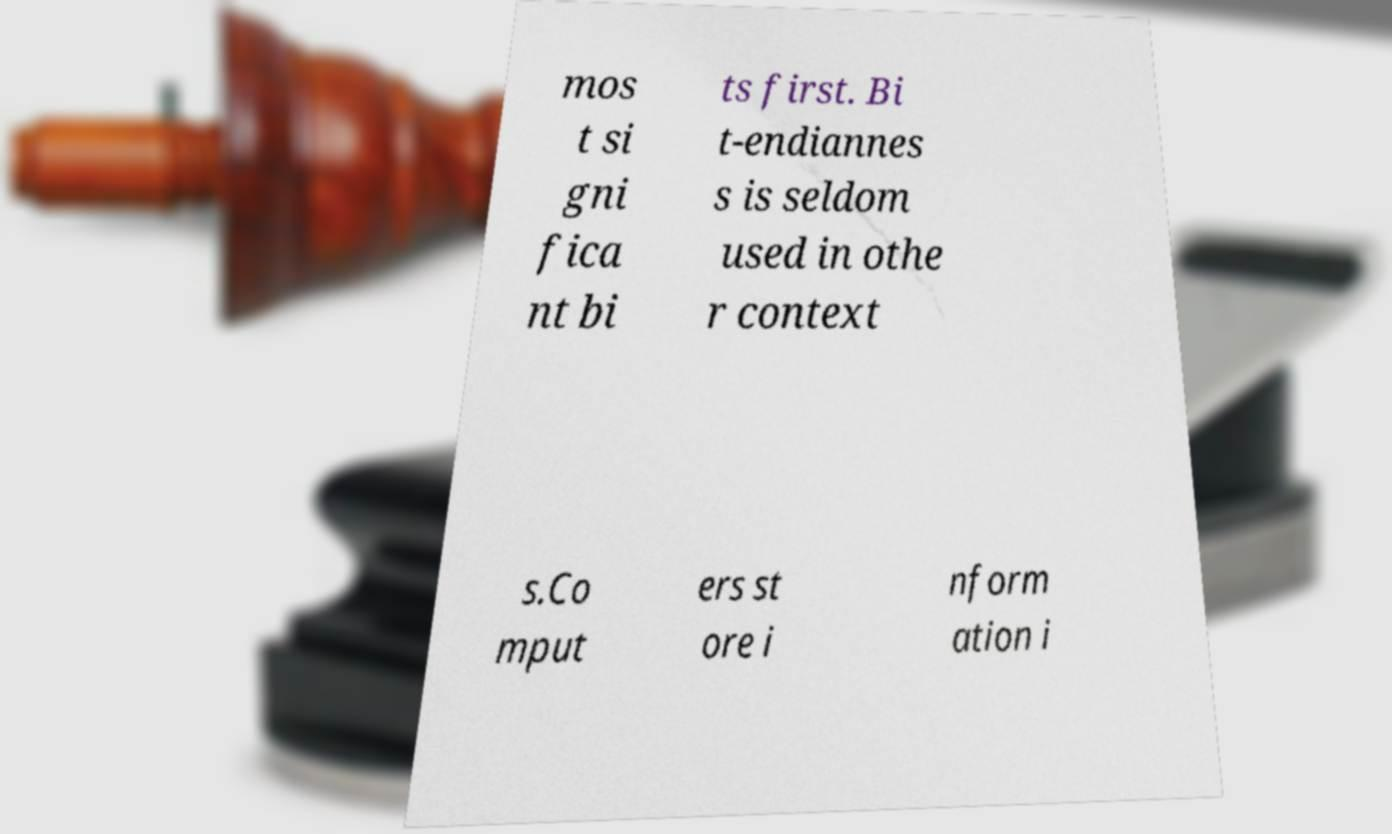Please identify and transcribe the text found in this image. mos t si gni fica nt bi ts first. Bi t-endiannes s is seldom used in othe r context s.Co mput ers st ore i nform ation i 